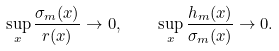Convert formula to latex. <formula><loc_0><loc_0><loc_500><loc_500>\sup _ { x } \frac { \sigma _ { m } ( x ) } { r ( x ) } \rightarrow 0 , \quad \sup _ { x } \frac { h _ { m } ( x ) } { \sigma _ { m } ( x ) } \rightarrow 0 .</formula> 